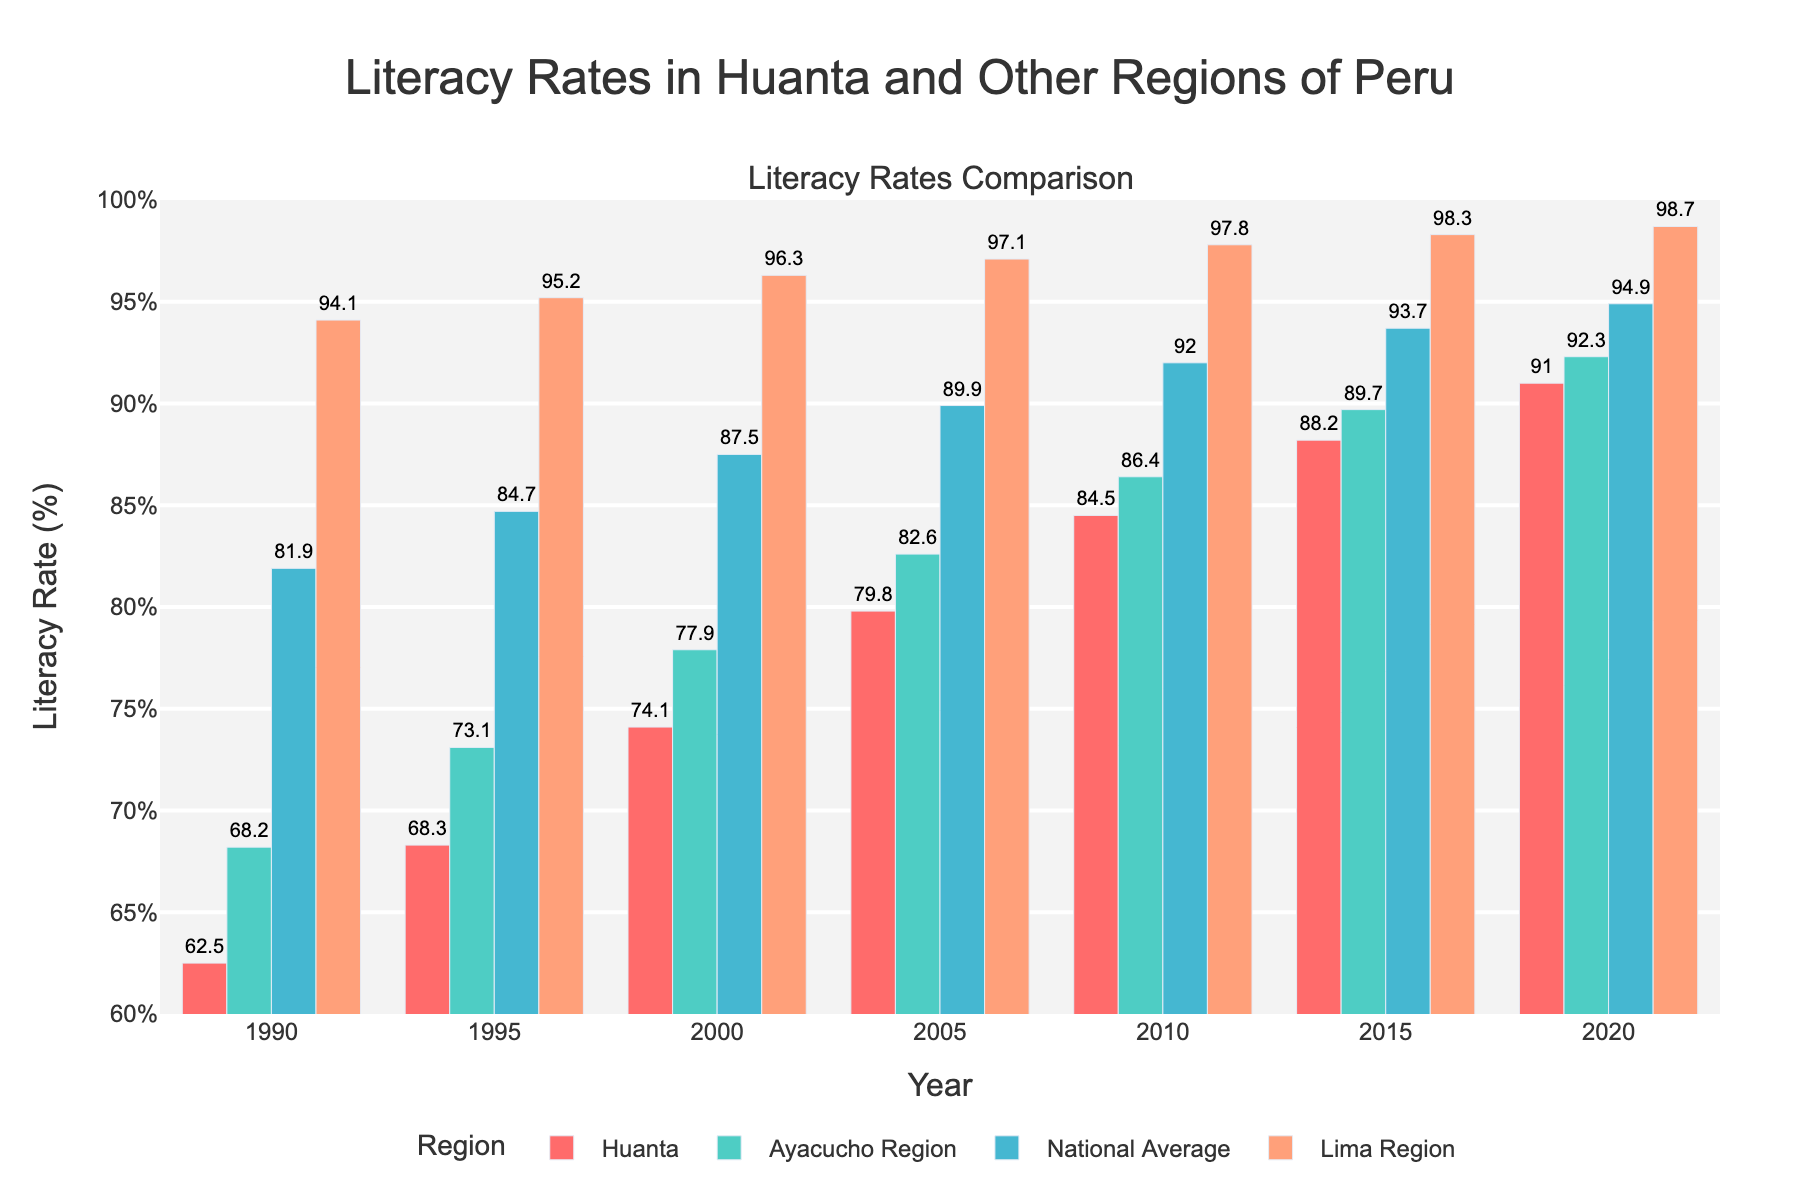What was the literacy rate in Huanta in the year 2000? Look at the bar representing Huanta for the year 2000 and read the literacy rate indicated.
Answer: 74.1% Which region had the highest literacy rate in 2010? Compare the heights of the bars for all regions in the year 2010 and identify the tallest one.
Answer: Lima Region How did the literacy rate change in Huanta from 1990 to 2020? Subtract the literacy rate in 1990 from the rate in 2020 for Huanta to determine the change.
Answer: 91.0% - 62.5% = 28.5% Between 1995 and 2005, which region showed the highest improvement in literacy rates? Calculate the difference in literacy rates between 1995 and 2005 for each region and identify the region with the largest increase.
Answer: Huanta (79.8% - 68.3% = 11.5%) Compare the literacy rates of Huanta and Lima Region in 2020. Look at the bars for both Huanta and Lima Region in 2020 and compare their heights (literacy rates).
Answer: Lima Region had a higher literacy rate (98.7% vs 91.0%) What is the average literacy rate of Huanta over the given years? Add the literacy rates for Huanta from all years and divide by the number of years to find the average.
Answer: (62.5% + 68.3% + 74.1% + 79.8% + 84.5% + 88.2% + 91.0%) / 7 = 78.34% Which region consistently had the highest literacy rates across all years shown? Compare the bars for each region across all years and identify the region with the highest bars consistently.
Answer: Lima Region By how much did the national average literacy rate increase from 1990 to 2020? Subtract the literacy rate of the national average in 1990 from that in 2020 to find the increase.
Answer: 94.9% - 81.9% = 13.0% In 2015, did Huanta's literacy rate exceed the national average? Compare Huanta's literacy rate bar with the national average literacy rate bar for the year 2015.
Answer: No (88.2% vs 93.7%) Which region had the slowest improvement in literacy rates from 1990 to 2020? Calculate the difference in literacy rates between 1990 and 2020 for each region and identify the region with the smallest increase.
Answer: National Average (94.9% - 81.9% = 13%) 